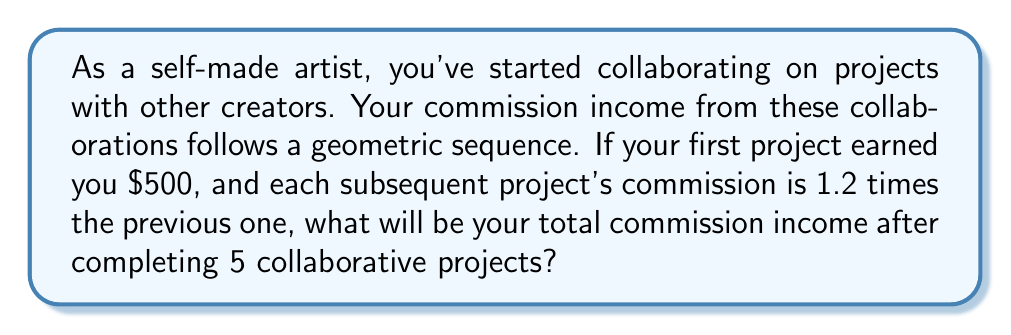Can you solve this math problem? Let's approach this step-by-step:

1) We're dealing with a geometric sequence where:
   - First term, $a = 500$
   - Common ratio, $r = 1.2$
   - Number of terms, $n = 5$

2) The formula for the sum of a geometric sequence is:

   $$S_n = \frac{a(1-r^n)}{1-r}$$

   Where $S_n$ is the sum of $n$ terms.

3) Let's substitute our values:

   $$S_5 = \frac{500(1-1.2^5)}{1-1.2}$$

4) Calculate $1.2^5$:
   $$1.2^5 = 2.48832$$

5) Now our equation looks like:

   $$S_5 = \frac{500(1-2.48832)}{1-1.2} = \frac{500(-1.48832)}{-0.2}$$

6) Simplify:
   $$S_5 = \frac{744.16}{0.2} = 3720.8$$

Therefore, the total commission income after 5 projects will be $3720.80.
Answer: $3720.80 